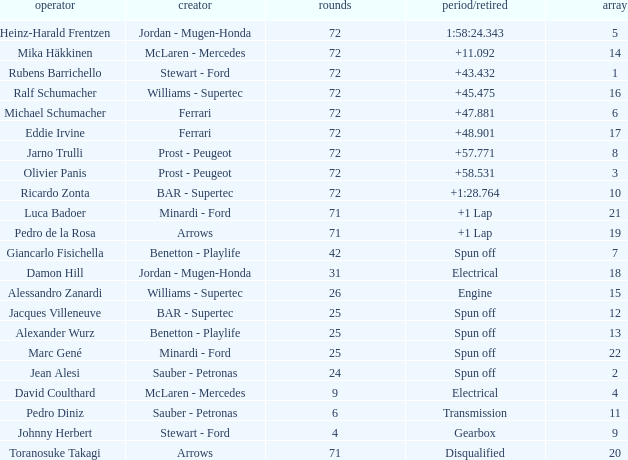What was Alexander Wurz's highest grid with laps of less than 25? None. 